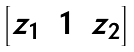<formula> <loc_0><loc_0><loc_500><loc_500>\begin{bmatrix} z _ { 1 } & 1 & z _ { 2 } \end{bmatrix}</formula> 